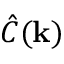<formula> <loc_0><loc_0><loc_500><loc_500>{ \hat { C } } ( k )</formula> 